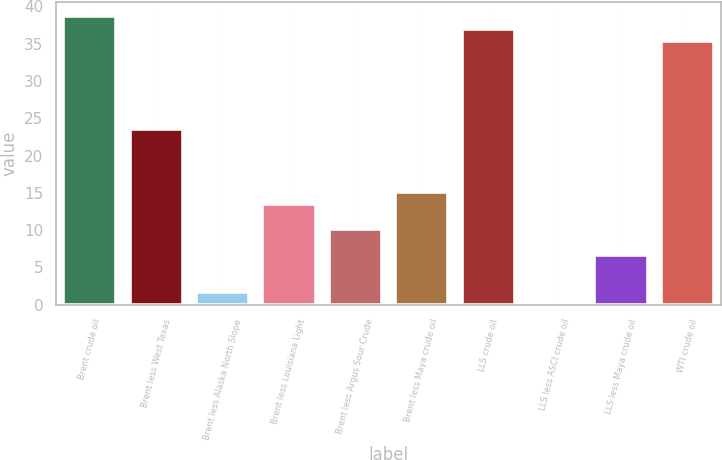Convert chart. <chart><loc_0><loc_0><loc_500><loc_500><bar_chart><fcel>Brent crude oil<fcel>Brent less West Texas<fcel>Brent less Alaska North Slope<fcel>Brent less Louisiana Light<fcel>Brent less Argus Sour Crude<fcel>Brent less Maya crude oil<fcel>LLS crude oil<fcel>LLS less ASCI crude oil<fcel>LLS less Maya crude oil<fcel>WTI crude oil<nl><fcel>38.65<fcel>23.53<fcel>1.69<fcel>13.45<fcel>10.09<fcel>15.13<fcel>36.97<fcel>0.01<fcel>6.73<fcel>35.29<nl></chart> 